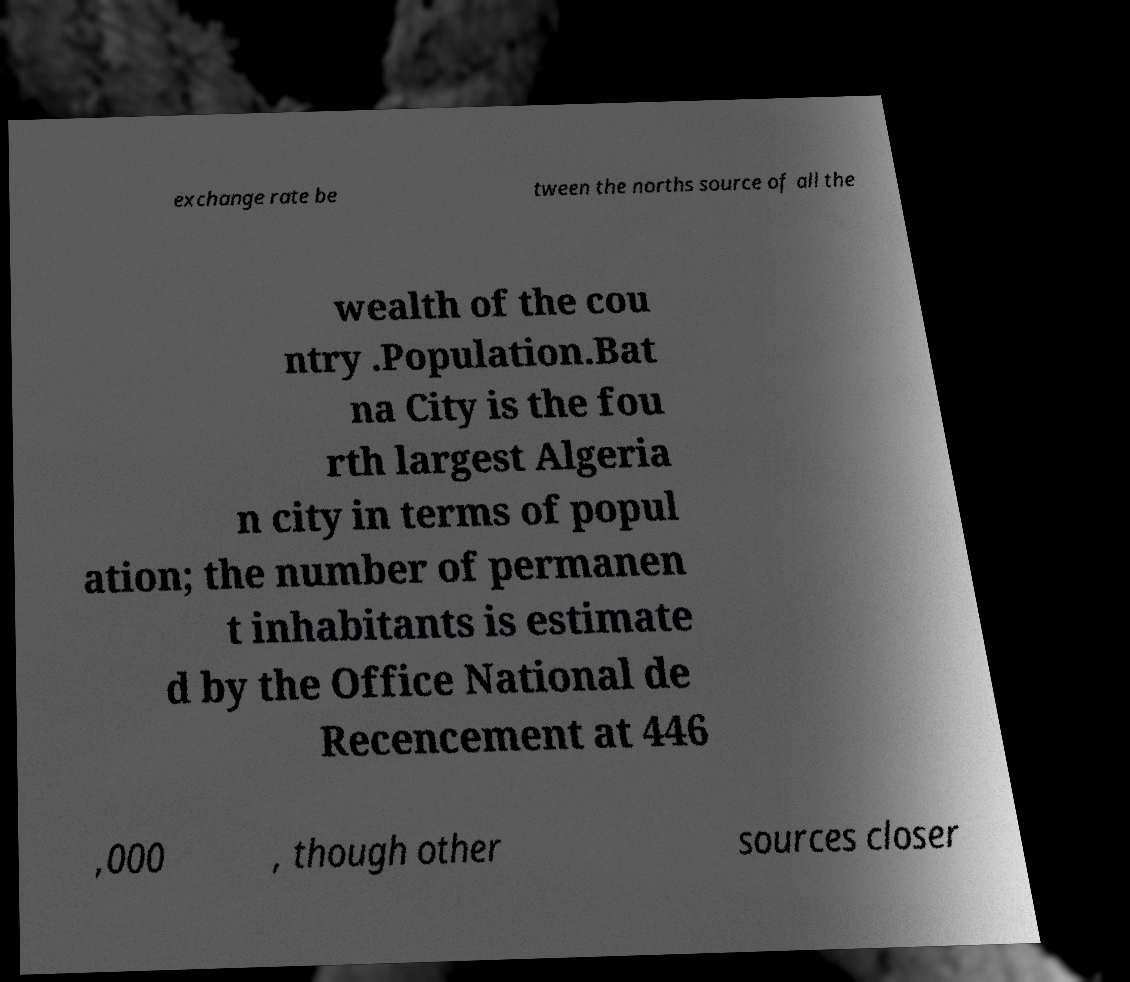Could you extract and type out the text from this image? exchange rate be tween the norths source of all the wealth of the cou ntry .Population.Bat na City is the fou rth largest Algeria n city in terms of popul ation; the number of permanen t inhabitants is estimate d by the Office National de Recencement at 446 ,000 , though other sources closer 